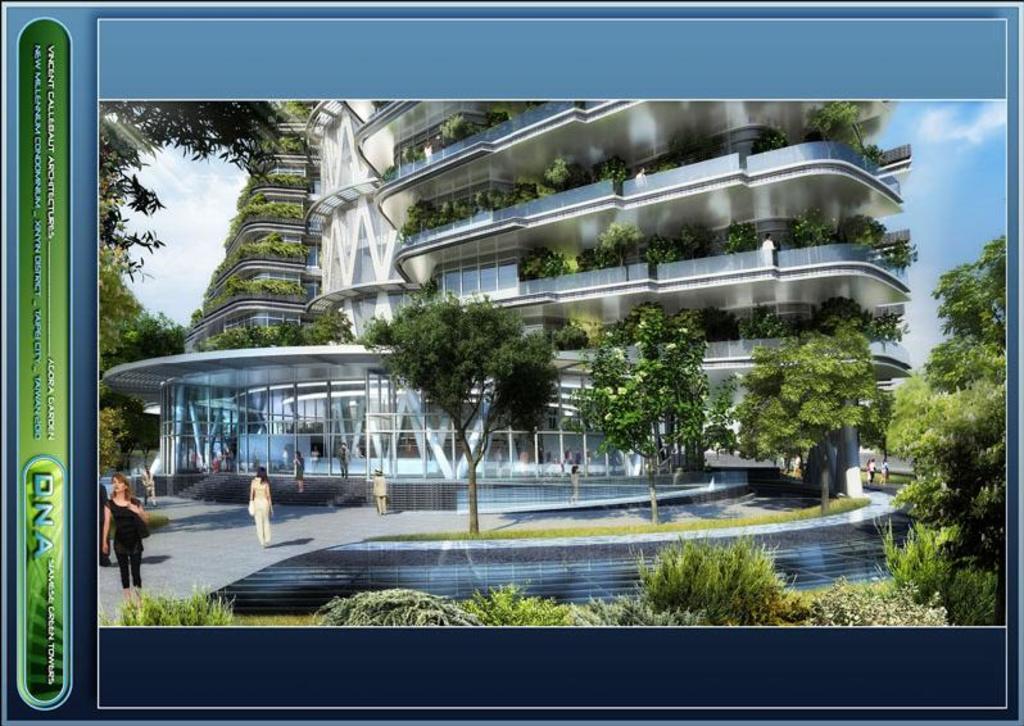Describe this image in one or two sentences. In the center of the image we can see the sky, clouds, one building, fences, trees, plants, grass, poles, few people are standing, few people are holding some objects and a few other objects. On the left side of the image, we can see some text.  